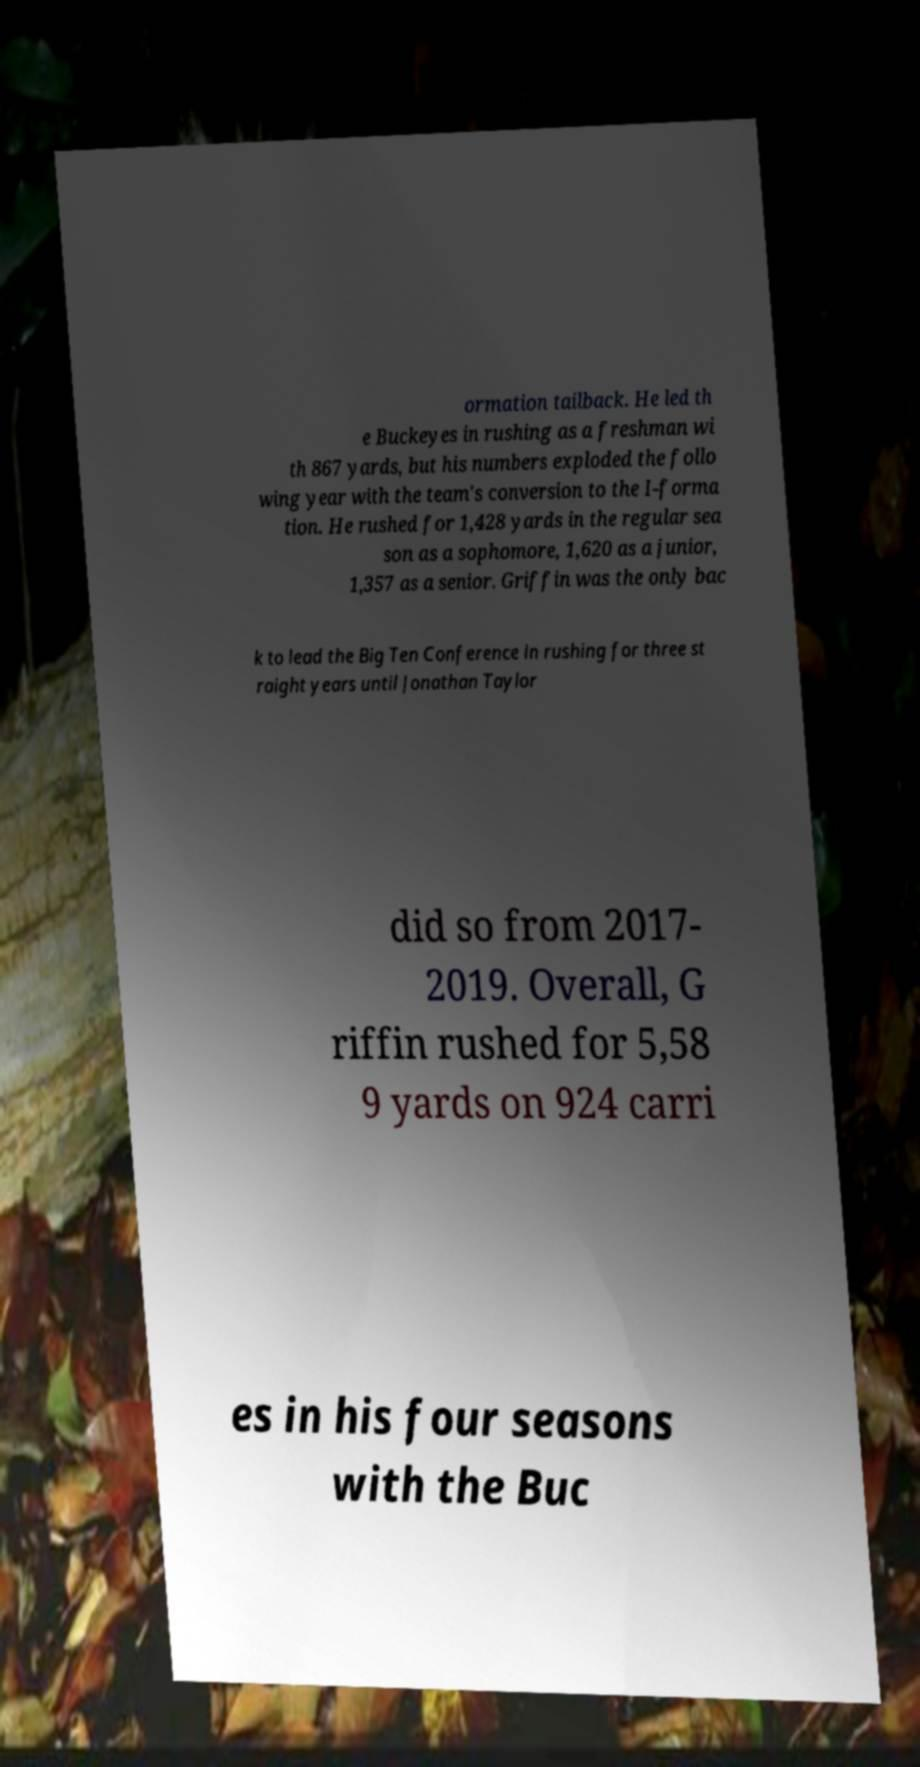Could you assist in decoding the text presented in this image and type it out clearly? ormation tailback. He led th e Buckeyes in rushing as a freshman wi th 867 yards, but his numbers exploded the follo wing year with the team's conversion to the I-forma tion. He rushed for 1,428 yards in the regular sea son as a sophomore, 1,620 as a junior, 1,357 as a senior. Griffin was the only bac k to lead the Big Ten Conference in rushing for three st raight years until Jonathan Taylor did so from 2017- 2019. Overall, G riffin rushed for 5,58 9 yards on 924 carri es in his four seasons with the Buc 